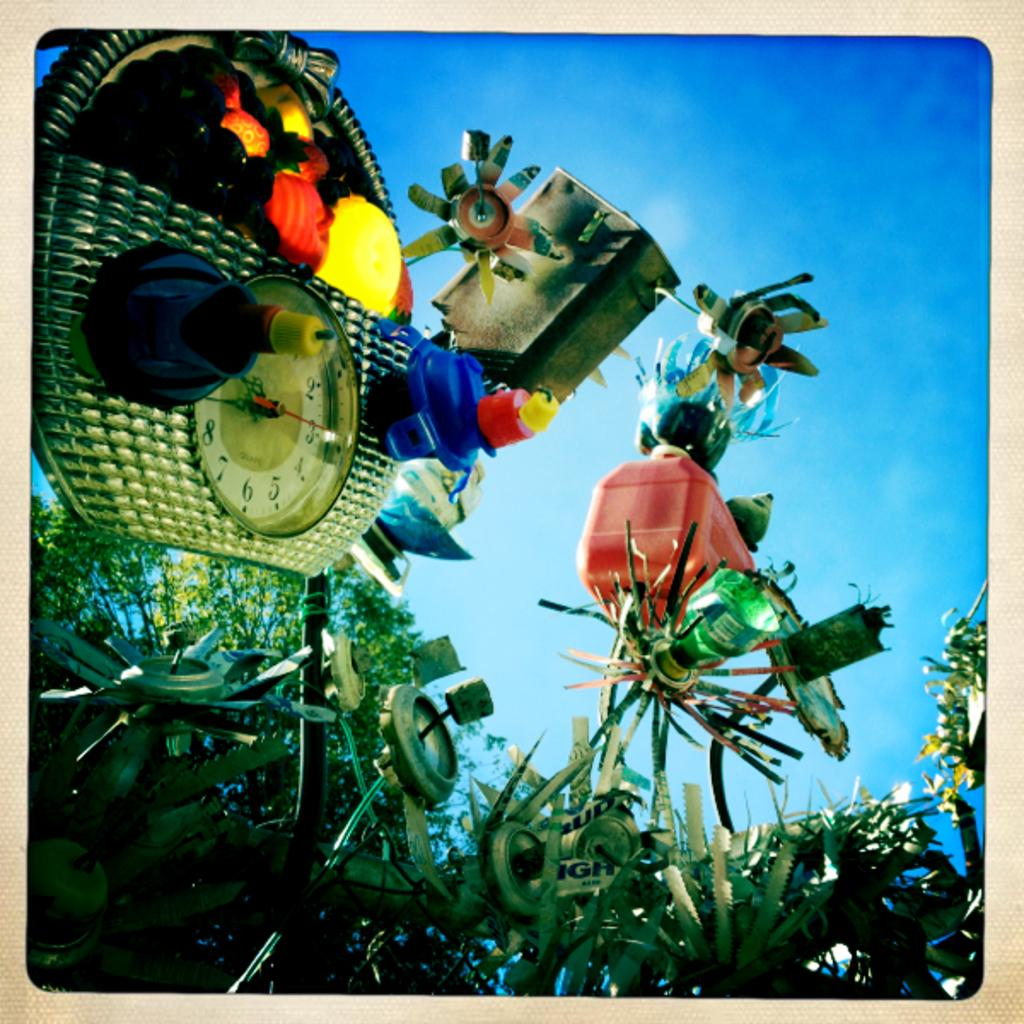What is the main object in the image? There is a clock in the image. Where is the clock located? The clock is on an object on the left side of the image. What type of materials can be seen in the image? There is scrap with plastic and other materials visible in the image. What else can be seen in the image besides the clock and scrap materials? There are other objects visible in the image. What is visible in the background of the image? The sky is visible in the image. What type of letter is being written in the image? There is no letter being written in the image; it features a clock, scrap materials, and other objects. What kind of meat can be seen cooking in the image? There is no meat or cooking activity present in the image. 